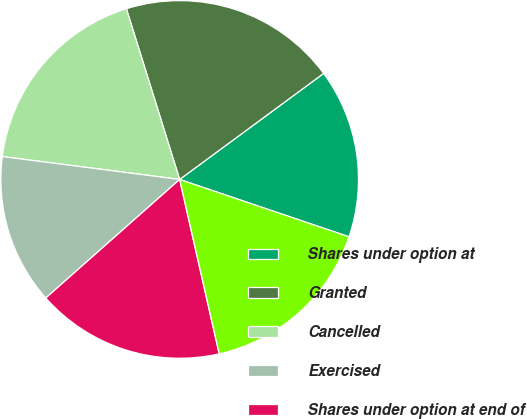Convert chart to OTSL. <chart><loc_0><loc_0><loc_500><loc_500><pie_chart><fcel>Shares under option at<fcel>Granted<fcel>Cancelled<fcel>Exercised<fcel>Shares under option at end of<fcel>Exercisable at end of year<nl><fcel>15.3%<fcel>19.71%<fcel>18.14%<fcel>13.58%<fcel>17.01%<fcel>16.25%<nl></chart> 